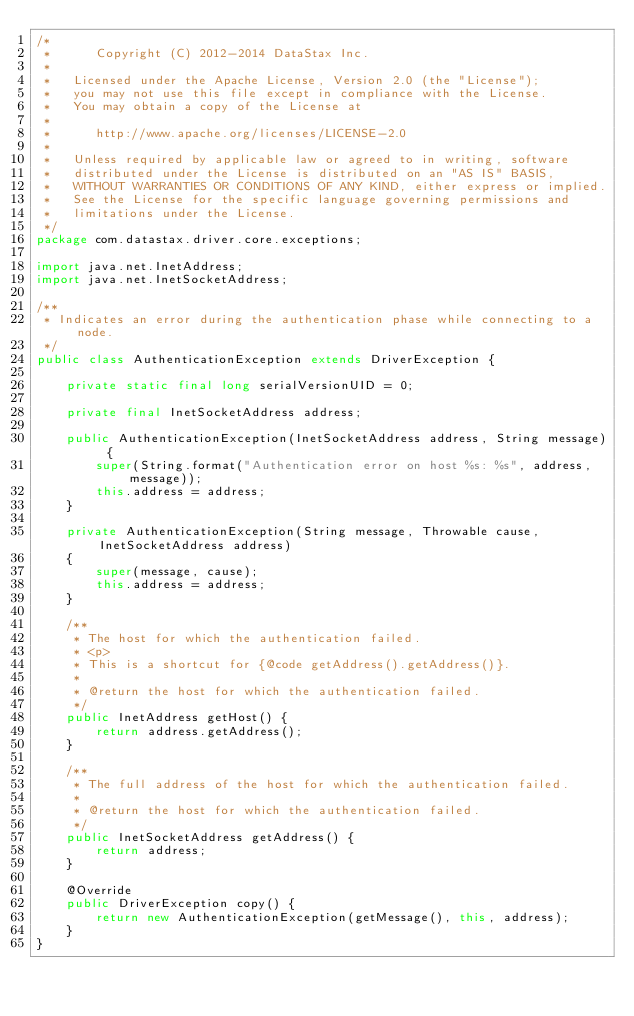<code> <loc_0><loc_0><loc_500><loc_500><_Java_>/*
 *      Copyright (C) 2012-2014 DataStax Inc.
 *
 *   Licensed under the Apache License, Version 2.0 (the "License");
 *   you may not use this file except in compliance with the License.
 *   You may obtain a copy of the License at
 *
 *      http://www.apache.org/licenses/LICENSE-2.0
 *
 *   Unless required by applicable law or agreed to in writing, software
 *   distributed under the License is distributed on an "AS IS" BASIS,
 *   WITHOUT WARRANTIES OR CONDITIONS OF ANY KIND, either express or implied.
 *   See the License for the specific language governing permissions and
 *   limitations under the License.
 */
package com.datastax.driver.core.exceptions;

import java.net.InetAddress;
import java.net.InetSocketAddress;

/**
 * Indicates an error during the authentication phase while connecting to a node.
 */
public class AuthenticationException extends DriverException {

    private static final long serialVersionUID = 0;

    private final InetSocketAddress address;

    public AuthenticationException(InetSocketAddress address, String message) {
        super(String.format("Authentication error on host %s: %s", address, message));
        this.address = address;
    }

    private AuthenticationException(String message, Throwable cause, InetSocketAddress address)
    {
        super(message, cause);
        this.address = address;
    }

    /**
     * The host for which the authentication failed.
     * <p>
     * This is a shortcut for {@code getAddress().getAddress()}.
     *
     * @return the host for which the authentication failed.
     */
    public InetAddress getHost() {
        return address.getAddress();
    }

    /**
     * The full address of the host for which the authentication failed.
     *
     * @return the host for which the authentication failed.
     */
    public InetSocketAddress getAddress() {
        return address;
    }

    @Override
    public DriverException copy() {
        return new AuthenticationException(getMessage(), this, address);
    }
}
</code> 